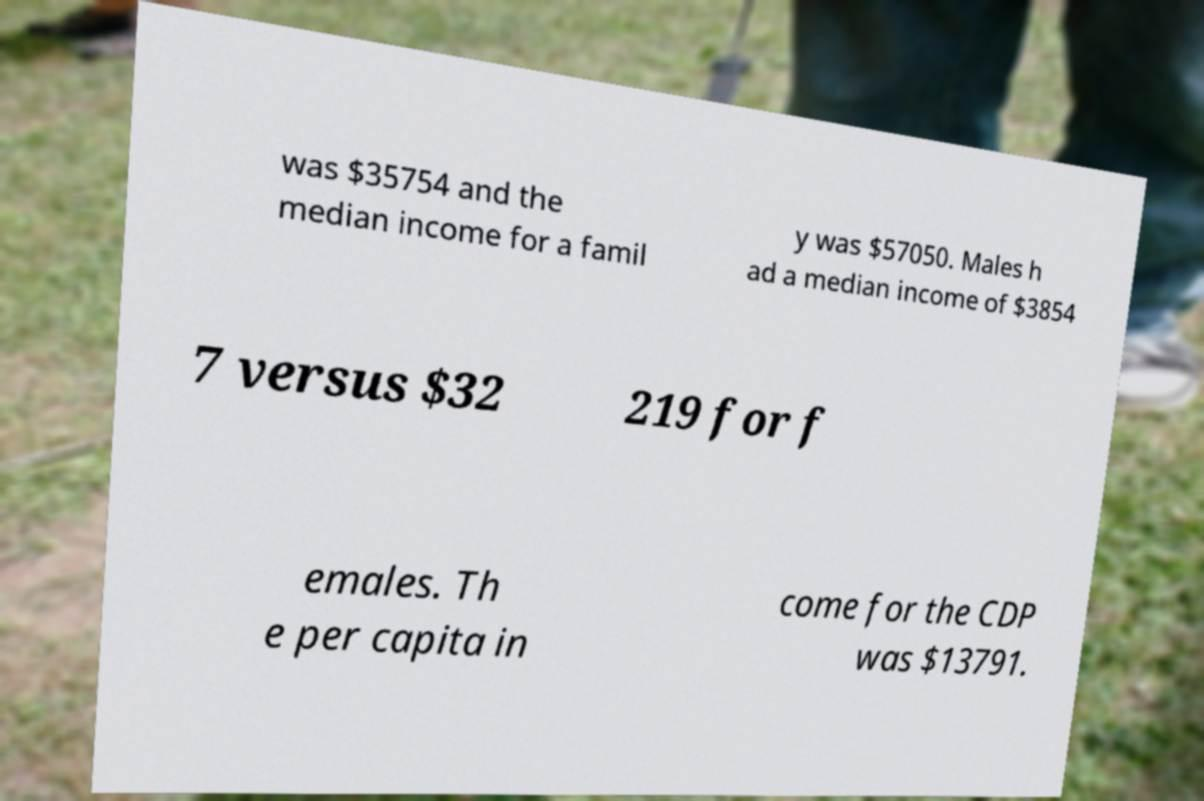Please read and relay the text visible in this image. What does it say? was $35754 and the median income for a famil y was $57050. Males h ad a median income of $3854 7 versus $32 219 for f emales. Th e per capita in come for the CDP was $13791. 